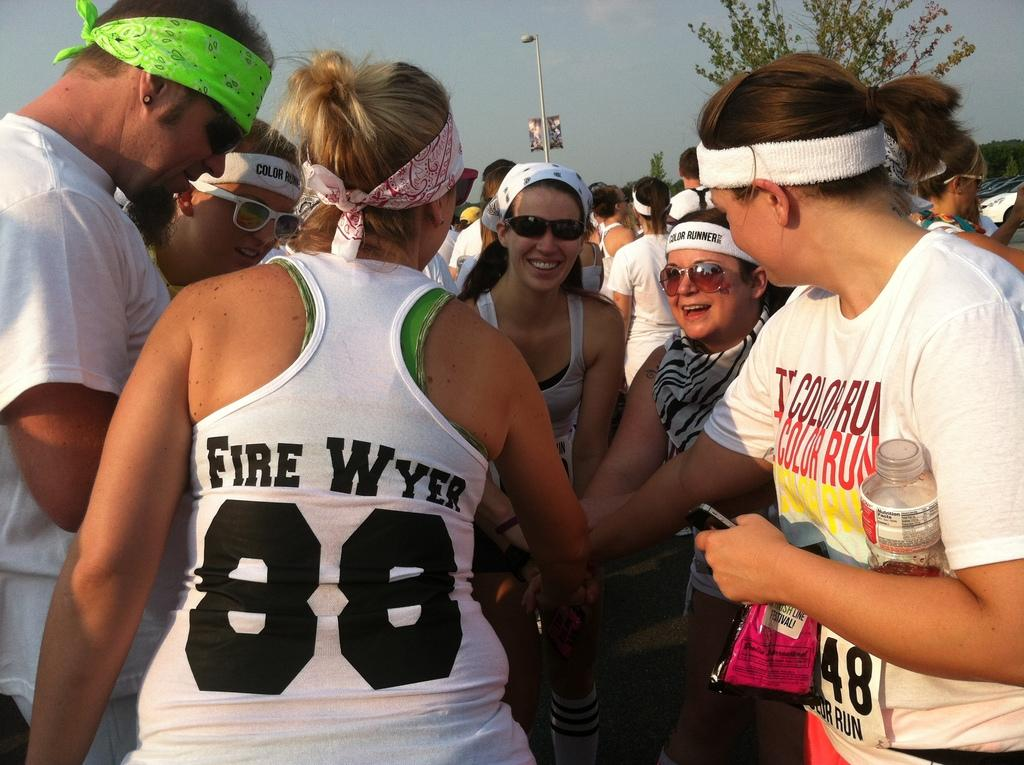Provide a one-sentence caption for the provided image. the lady wearing Fire Wyer 88 top is cheering with others. 